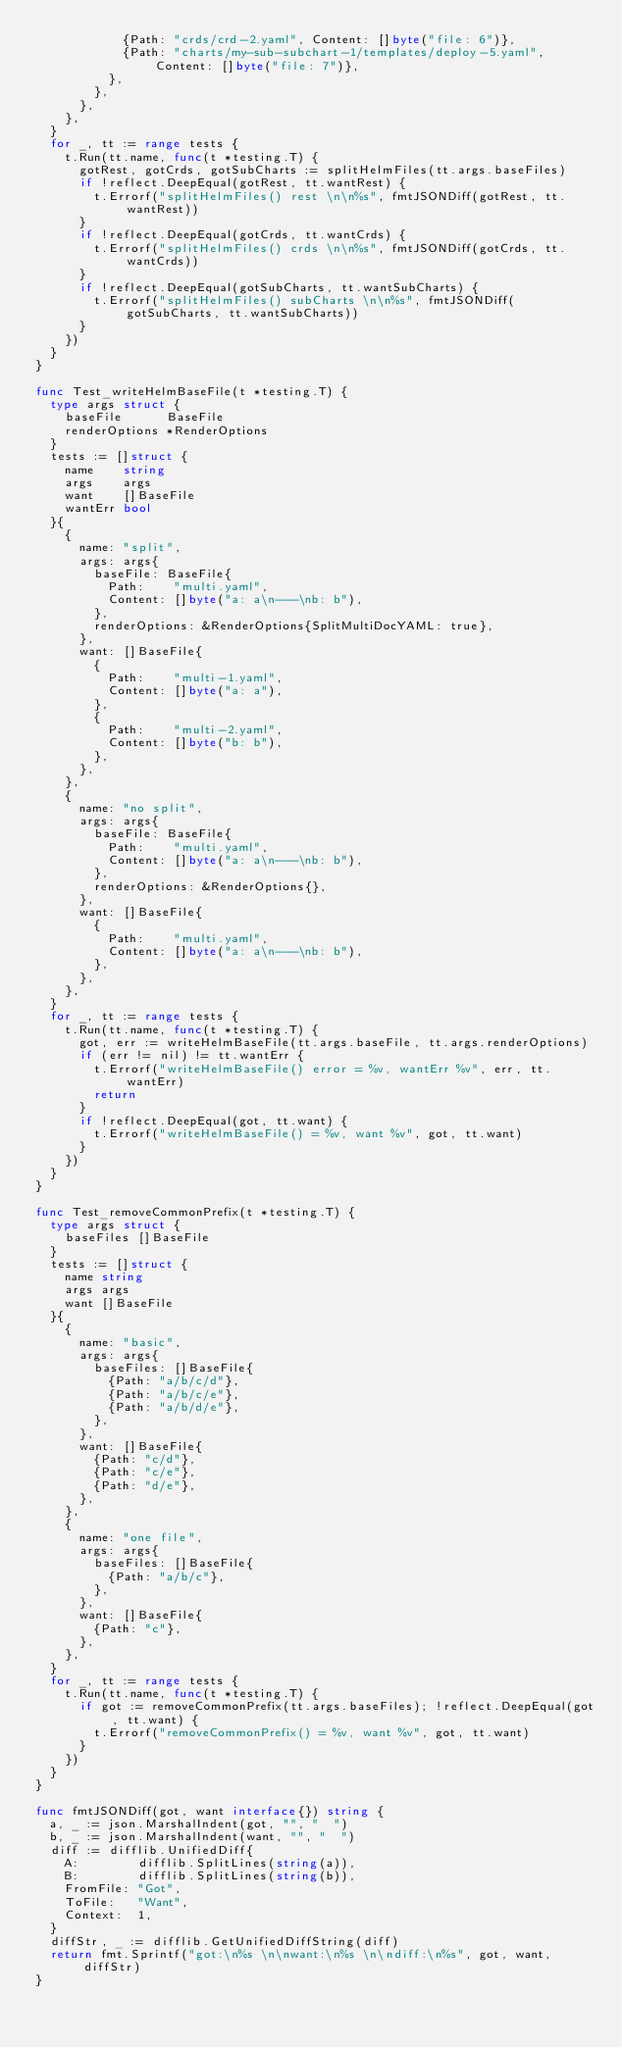<code> <loc_0><loc_0><loc_500><loc_500><_Go_>						{Path: "crds/crd-2.yaml", Content: []byte("file: 6")},
						{Path: "charts/my-sub-subchart-1/templates/deploy-5.yaml", Content: []byte("file: 7")},
					},
				},
			},
		},
	}
	for _, tt := range tests {
		t.Run(tt.name, func(t *testing.T) {
			gotRest, gotCrds, gotSubCharts := splitHelmFiles(tt.args.baseFiles)
			if !reflect.DeepEqual(gotRest, tt.wantRest) {
				t.Errorf("splitHelmFiles() rest \n\n%s", fmtJSONDiff(gotRest, tt.wantRest))
			}
			if !reflect.DeepEqual(gotCrds, tt.wantCrds) {
				t.Errorf("splitHelmFiles() crds \n\n%s", fmtJSONDiff(gotCrds, tt.wantCrds))
			}
			if !reflect.DeepEqual(gotSubCharts, tt.wantSubCharts) {
				t.Errorf("splitHelmFiles() subCharts \n\n%s", fmtJSONDiff(gotSubCharts, tt.wantSubCharts))
			}
		})
	}
}

func Test_writeHelmBaseFile(t *testing.T) {
	type args struct {
		baseFile      BaseFile
		renderOptions *RenderOptions
	}
	tests := []struct {
		name    string
		args    args
		want    []BaseFile
		wantErr bool
	}{
		{
			name: "split",
			args: args{
				baseFile: BaseFile{
					Path:    "multi.yaml",
					Content: []byte("a: a\n---\nb: b"),
				},
				renderOptions: &RenderOptions{SplitMultiDocYAML: true},
			},
			want: []BaseFile{
				{
					Path:    "multi-1.yaml",
					Content: []byte("a: a"),
				},
				{
					Path:    "multi-2.yaml",
					Content: []byte("b: b"),
				},
			},
		},
		{
			name: "no split",
			args: args{
				baseFile: BaseFile{
					Path:    "multi.yaml",
					Content: []byte("a: a\n---\nb: b"),
				},
				renderOptions: &RenderOptions{},
			},
			want: []BaseFile{
				{
					Path:    "multi.yaml",
					Content: []byte("a: a\n---\nb: b"),
				},
			},
		},
	}
	for _, tt := range tests {
		t.Run(tt.name, func(t *testing.T) {
			got, err := writeHelmBaseFile(tt.args.baseFile, tt.args.renderOptions)
			if (err != nil) != tt.wantErr {
				t.Errorf("writeHelmBaseFile() error = %v, wantErr %v", err, tt.wantErr)
				return
			}
			if !reflect.DeepEqual(got, tt.want) {
				t.Errorf("writeHelmBaseFile() = %v, want %v", got, tt.want)
			}
		})
	}
}

func Test_removeCommonPrefix(t *testing.T) {
	type args struct {
		baseFiles []BaseFile
	}
	tests := []struct {
		name string
		args args
		want []BaseFile
	}{
		{
			name: "basic",
			args: args{
				baseFiles: []BaseFile{
					{Path: "a/b/c/d"},
					{Path: "a/b/c/e"},
					{Path: "a/b/d/e"},
				},
			},
			want: []BaseFile{
				{Path: "c/d"},
				{Path: "c/e"},
				{Path: "d/e"},
			},
		},
		{
			name: "one file",
			args: args{
				baseFiles: []BaseFile{
					{Path: "a/b/c"},
				},
			},
			want: []BaseFile{
				{Path: "c"},
			},
		},
	}
	for _, tt := range tests {
		t.Run(tt.name, func(t *testing.T) {
			if got := removeCommonPrefix(tt.args.baseFiles); !reflect.DeepEqual(got, tt.want) {
				t.Errorf("removeCommonPrefix() = %v, want %v", got, tt.want)
			}
		})
	}
}

func fmtJSONDiff(got, want interface{}) string {
	a, _ := json.MarshalIndent(got, "", "  ")
	b, _ := json.MarshalIndent(want, "", "  ")
	diff := difflib.UnifiedDiff{
		A:        difflib.SplitLines(string(a)),
		B:        difflib.SplitLines(string(b)),
		FromFile: "Got",
		ToFile:   "Want",
		Context:  1,
	}
	diffStr, _ := difflib.GetUnifiedDiffString(diff)
	return fmt.Sprintf("got:\n%s \n\nwant:\n%s \n\ndiff:\n%s", got, want, diffStr)
}
</code> 